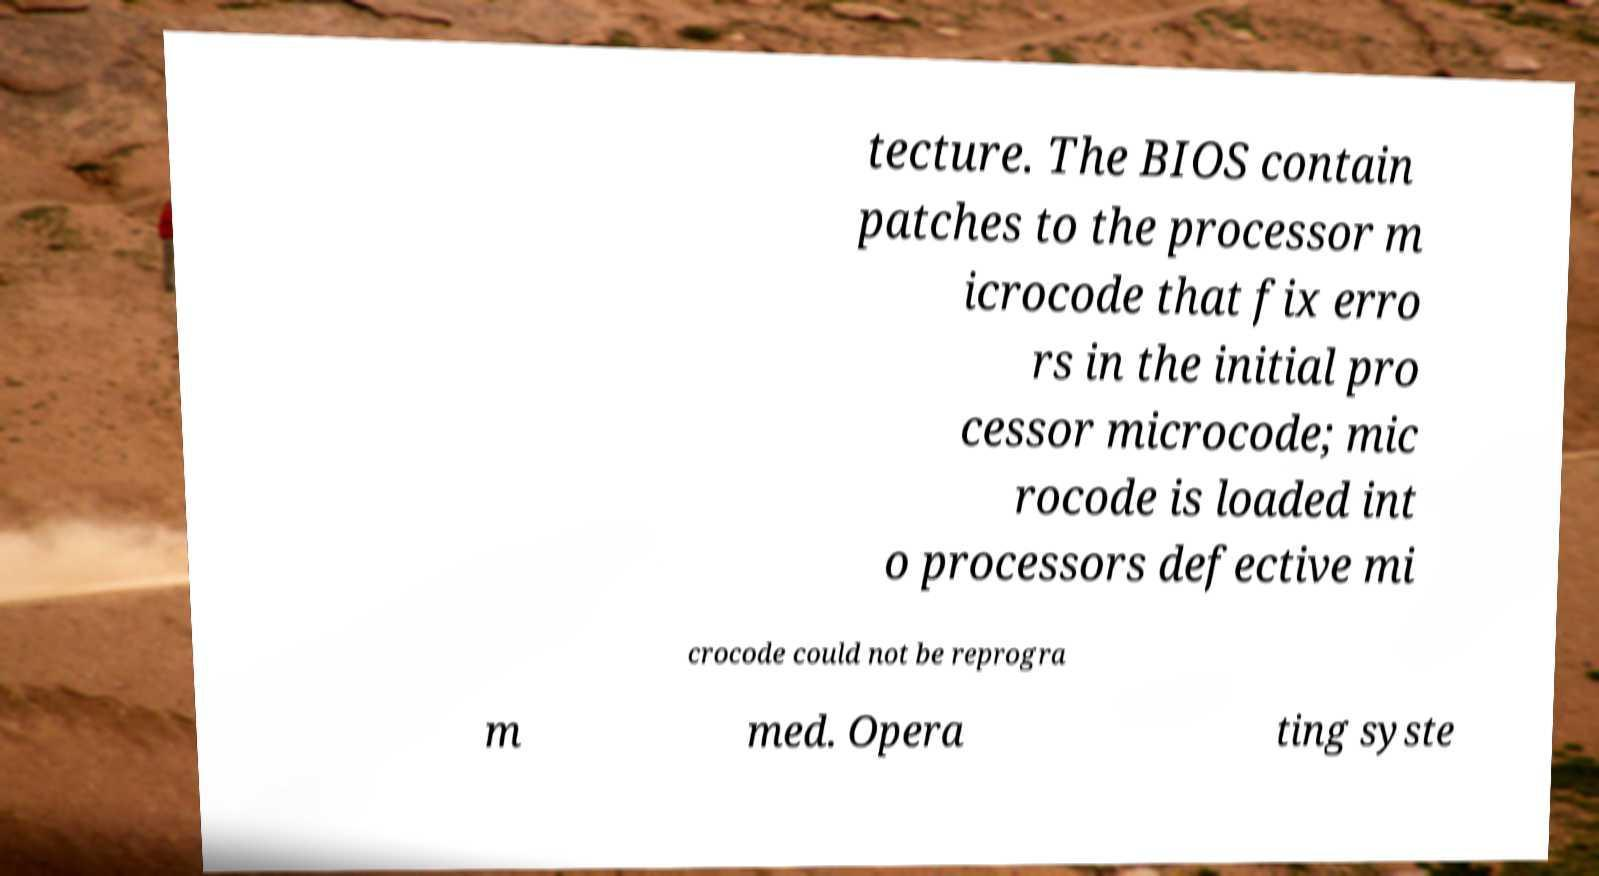Can you read and provide the text displayed in the image?This photo seems to have some interesting text. Can you extract and type it out for me? tecture. The BIOS contain patches to the processor m icrocode that fix erro rs in the initial pro cessor microcode; mic rocode is loaded int o processors defective mi crocode could not be reprogra m med. Opera ting syste 